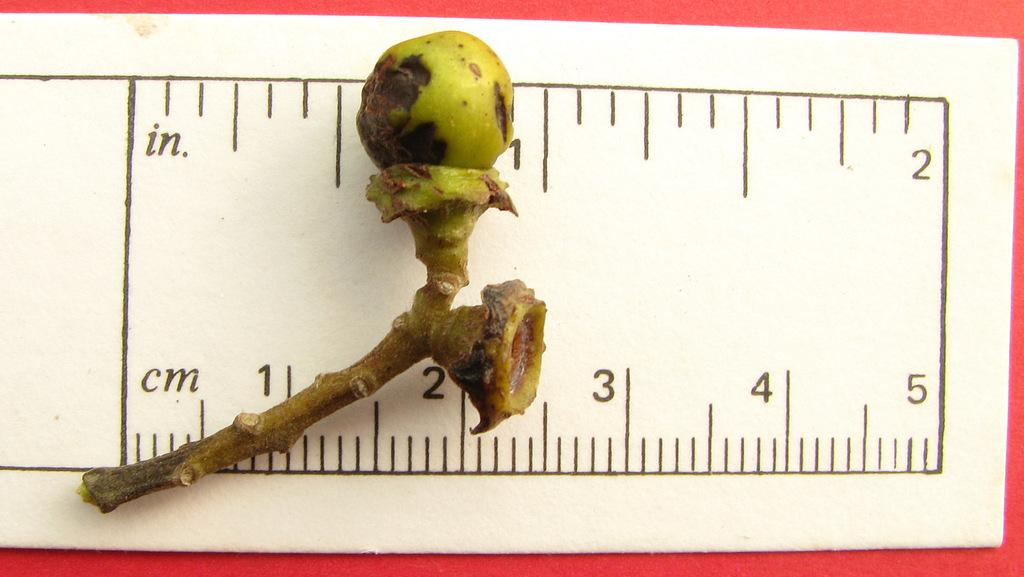Provide a one-sentence caption for the provided image. A dried up pod sitting on a ruler by the 1 inch mark. 